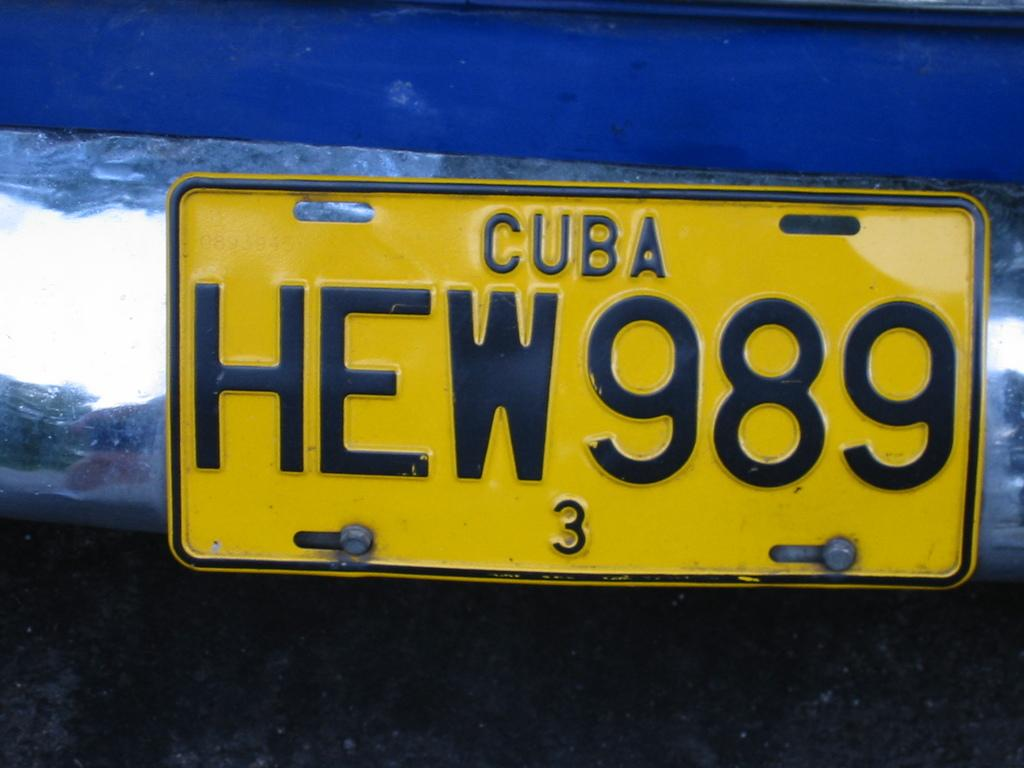<image>
Share a concise interpretation of the image provided. A blue vehicle from Cuba has the license plate number HEW989. 